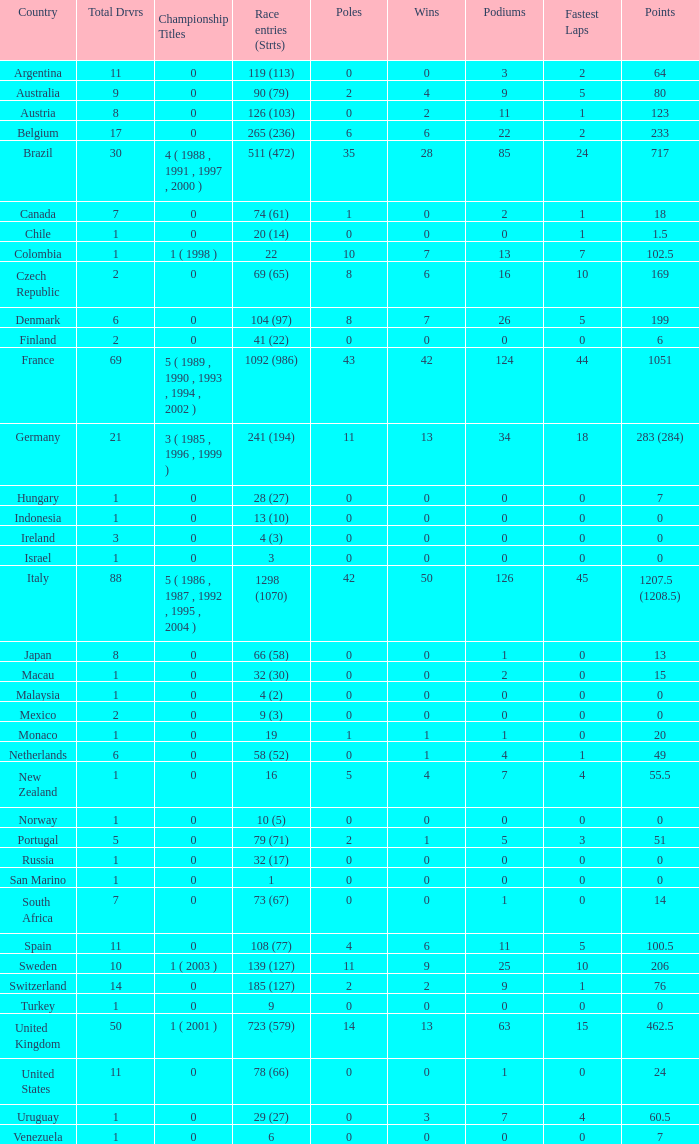How many fastest laps for the nation with 32 (30) entries and starts and fewer than 2 podiums? None. 